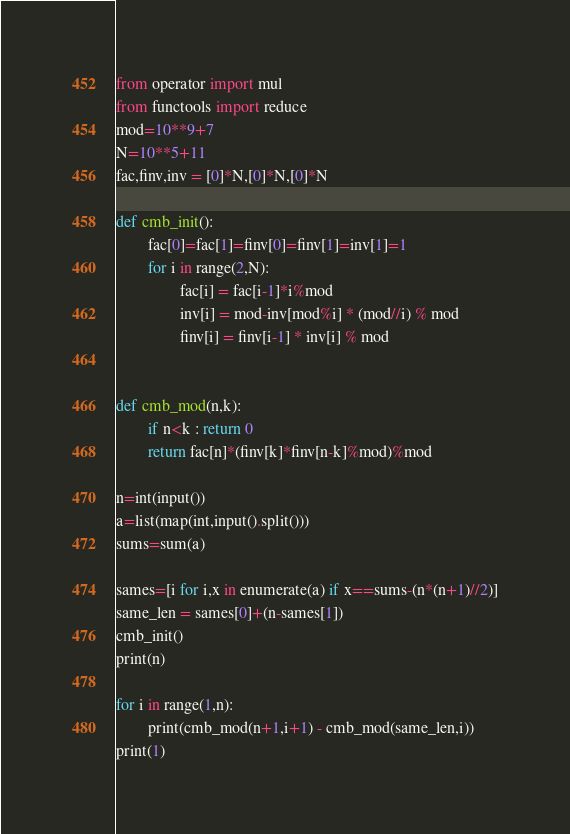<code> <loc_0><loc_0><loc_500><loc_500><_Python_>from operator import mul
from functools import reduce
mod=10**9+7
N=10**5+11
fac,finv,inv = [0]*N,[0]*N,[0]*N

def cmb_init():
        fac[0]=fac[1]=finv[0]=finv[1]=inv[1]=1
        for i in range(2,N):
                fac[i] = fac[i-1]*i%mod
                inv[i] = mod-inv[mod%i] * (mod//i) % mod
                finv[i] = finv[i-1] * inv[i] % mod


def cmb_mod(n,k):
        if n<k : return 0
        return fac[n]*(finv[k]*finv[n-k]%mod)%mod

n=int(input())
a=list(map(int,input().split()))
sums=sum(a)

sames=[i for i,x in enumerate(a) if x==sums-(n*(n+1)//2)]
same_len = sames[0]+(n-sames[1])
cmb_init()
print(n)

for i in range(1,n):
        print(cmb_mod(n+1,i+1) - cmb_mod(same_len,i))
print(1)</code> 